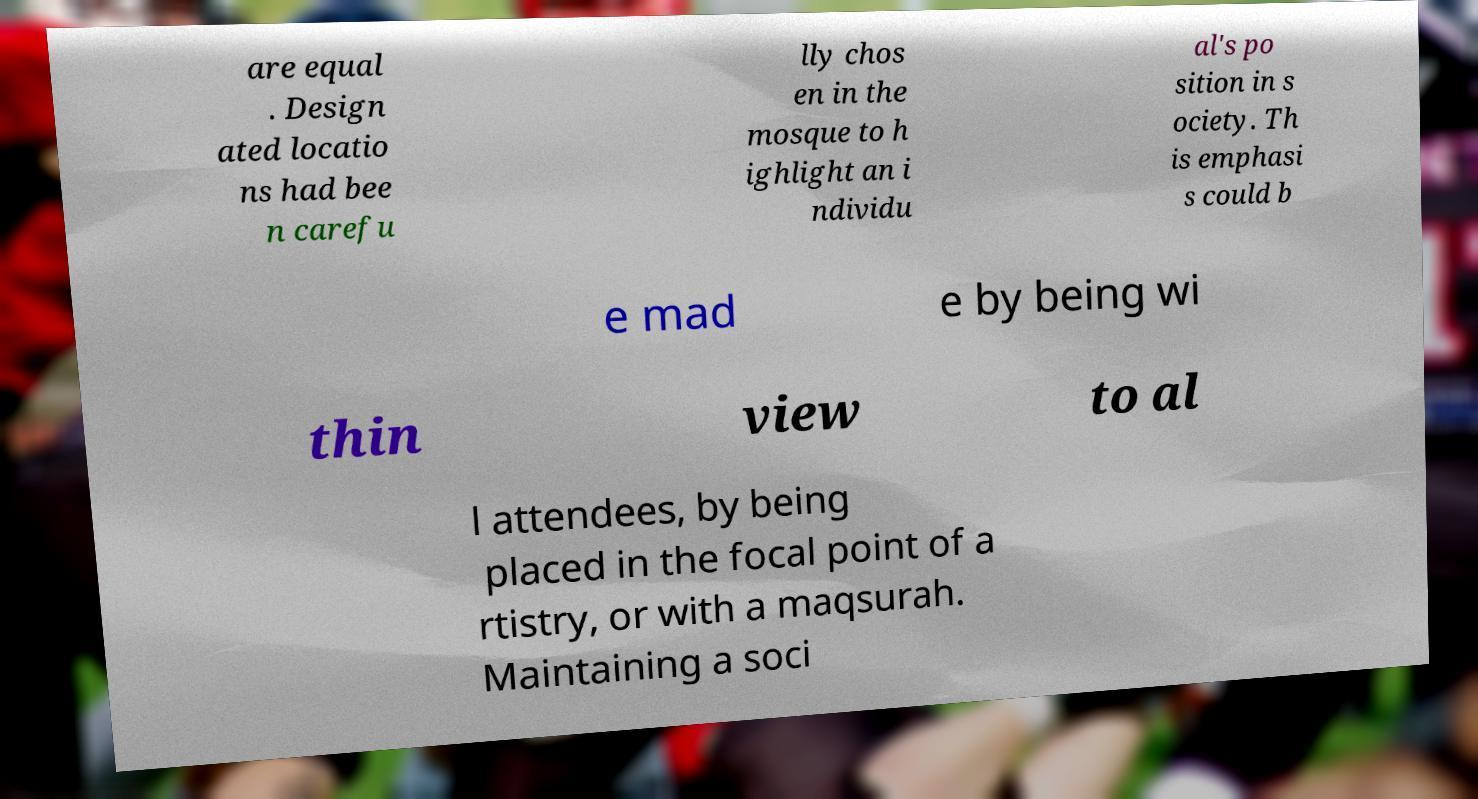What messages or text are displayed in this image? I need them in a readable, typed format. are equal . Design ated locatio ns had bee n carefu lly chos en in the mosque to h ighlight an i ndividu al's po sition in s ociety. Th is emphasi s could b e mad e by being wi thin view to al l attendees, by being placed in the focal point of a rtistry, or with a maqsurah. Maintaining a soci 